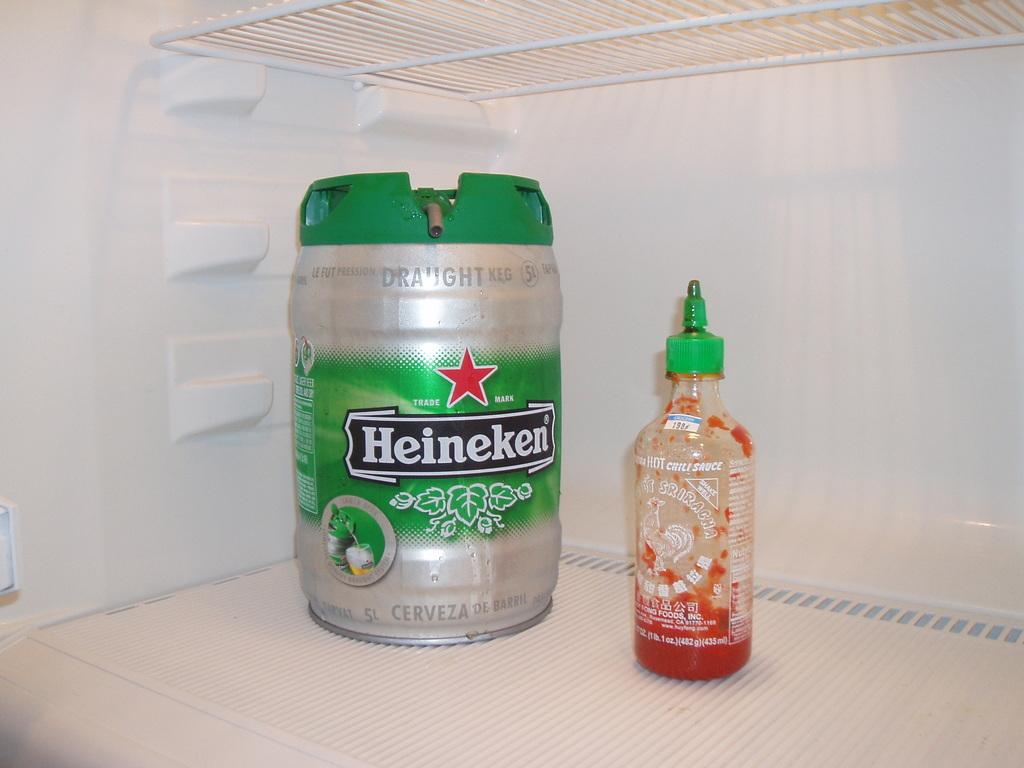<image>
Relay a brief, clear account of the picture shown. A small barrel of Heineken beer next to a bottle of hot sauce 